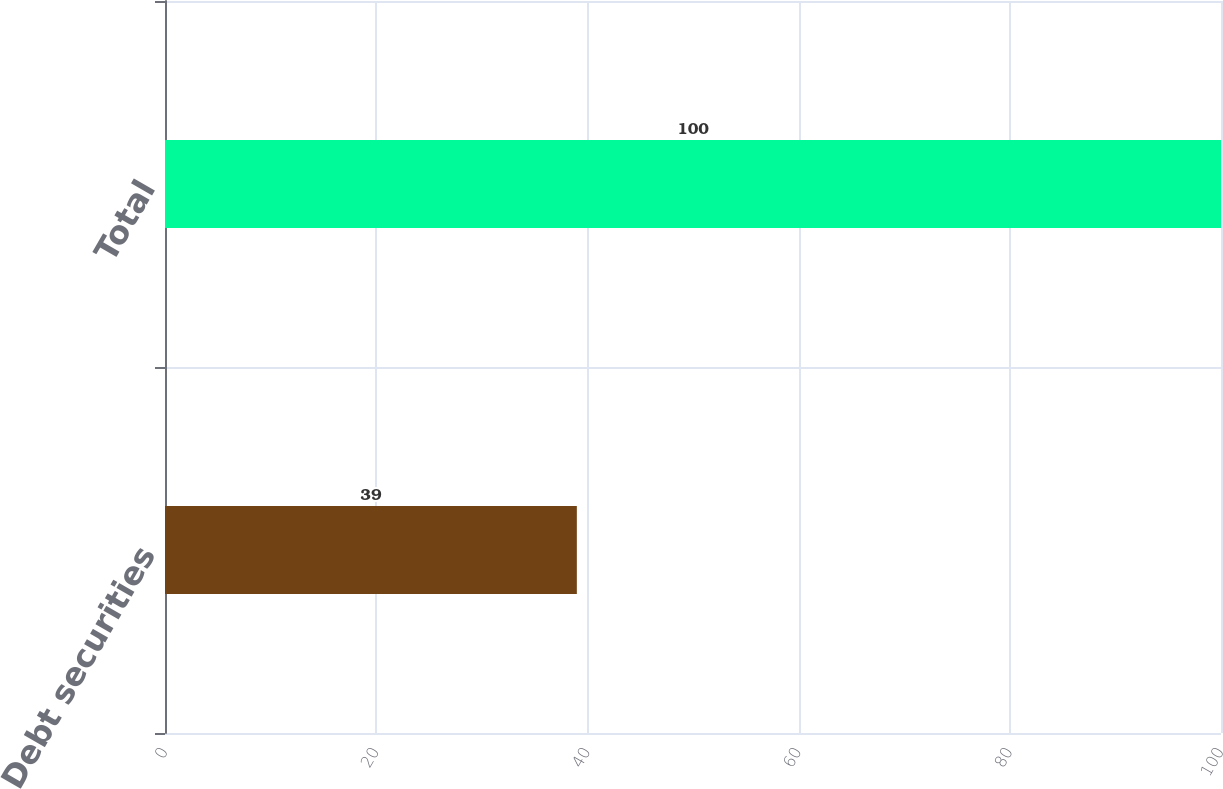<chart> <loc_0><loc_0><loc_500><loc_500><bar_chart><fcel>Debt securities<fcel>Total<nl><fcel>39<fcel>100<nl></chart> 